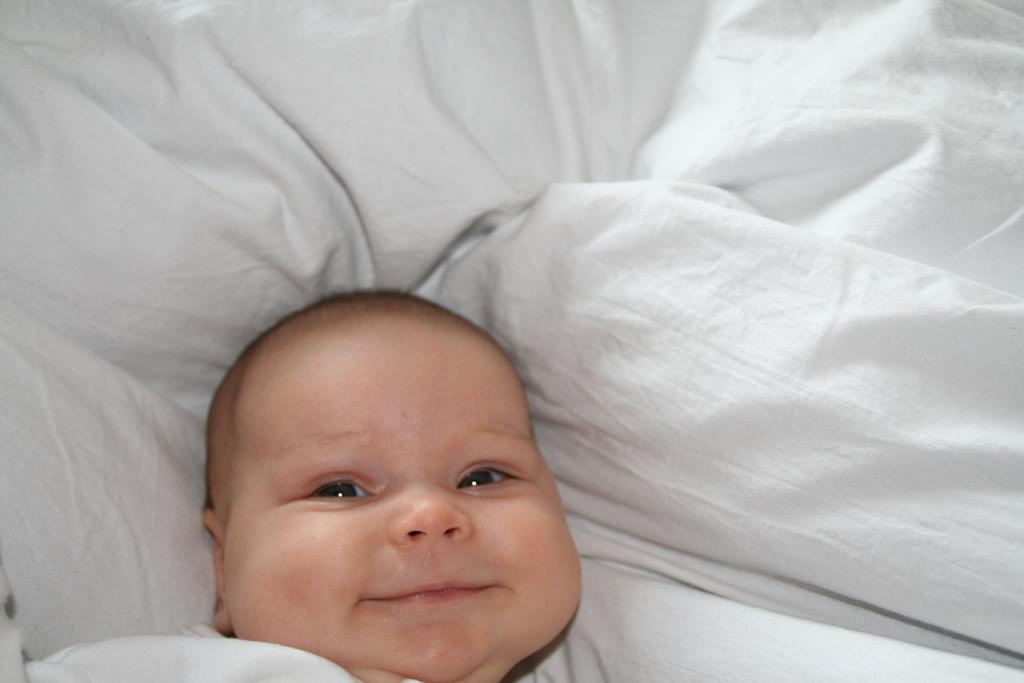What is the main subject of the image? The main subject of the image is a baby. What is the baby doing in the image? The baby is sleeping in the image. What is the baby lying on in the image? The baby is on a blanket in the image. What type of sign can be seen in the image? There is no sign present in the image; it features a baby sleeping on a blanket. What is the baby using to carry the crate in the image? There is no crate present in the image, and the baby is not carrying anything. 